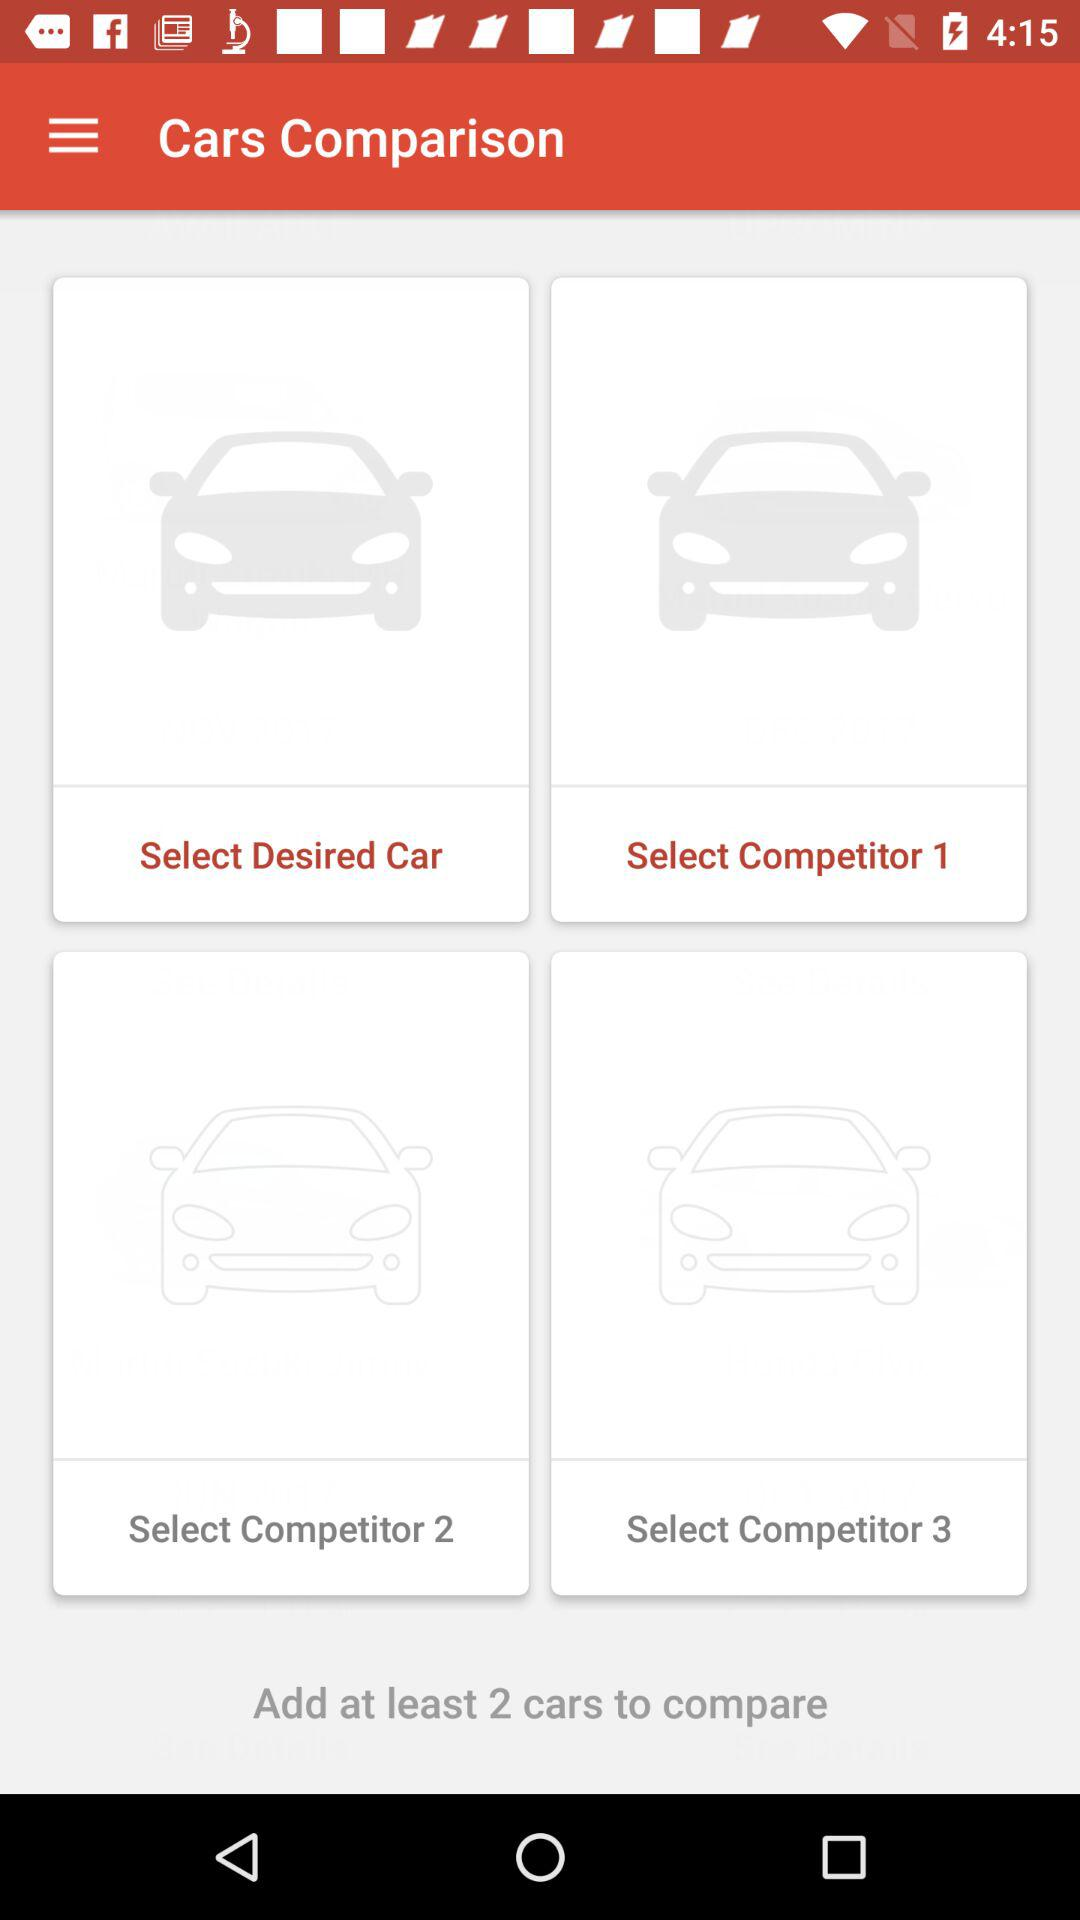How many cars have to be selected to compare them?
Answer the question using a single word or phrase. 2 